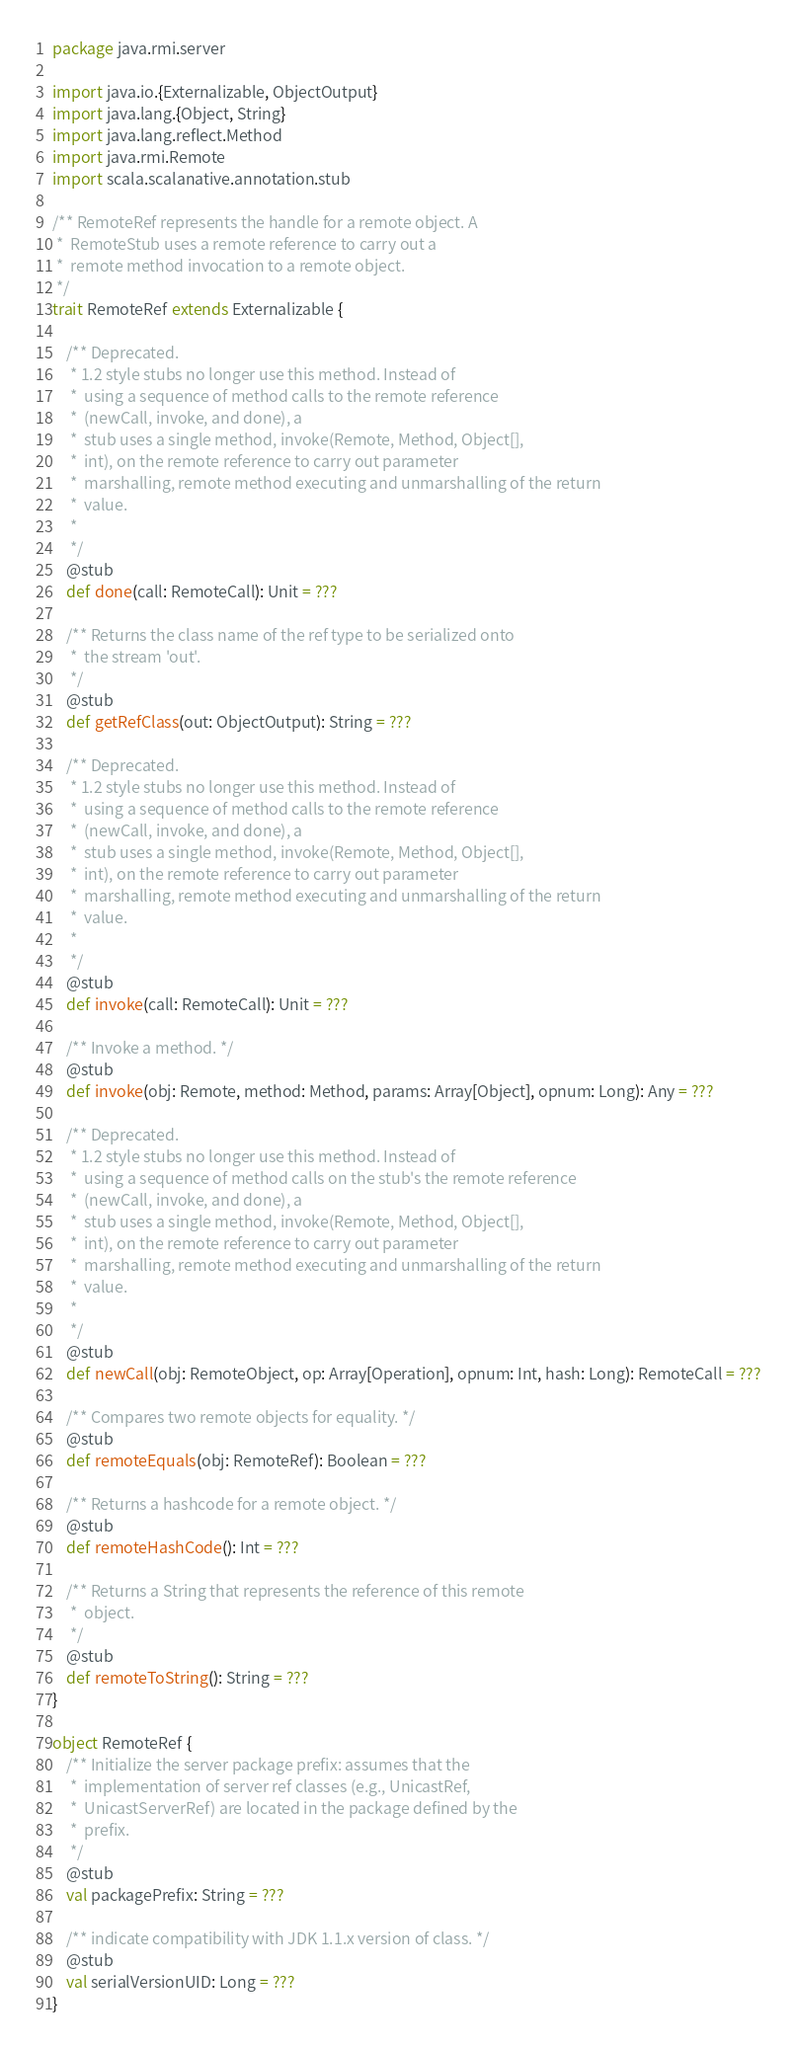Convert code to text. <code><loc_0><loc_0><loc_500><loc_500><_Scala_>package java.rmi.server

import java.io.{Externalizable, ObjectOutput}
import java.lang.{Object, String}
import java.lang.reflect.Method
import java.rmi.Remote
import scala.scalanative.annotation.stub

/** RemoteRef represents the handle for a remote object. A
 *  RemoteStub uses a remote reference to carry out a
 *  remote method invocation to a remote object.
 */
trait RemoteRef extends Externalizable {

    /** Deprecated. 
     * 1.2 style stubs no longer use this method. Instead of
     *  using a sequence of method calls to the remote reference
     *  (newCall, invoke, and done), a
     *  stub uses a single method, invoke(Remote, Method, Object[],
     *  int), on the remote reference to carry out parameter
     *  marshalling, remote method executing and unmarshalling of the return
     *  value.
     * 
     */
    @stub
    def done(call: RemoteCall): Unit = ???

    /** Returns the class name of the ref type to be serialized onto
     *  the stream 'out'.
     */
    @stub
    def getRefClass(out: ObjectOutput): String = ???

    /** Deprecated. 
     * 1.2 style stubs no longer use this method. Instead of
     *  using a sequence of method calls to the remote reference
     *  (newCall, invoke, and done), a
     *  stub uses a single method, invoke(Remote, Method, Object[],
     *  int), on the remote reference to carry out parameter
     *  marshalling, remote method executing and unmarshalling of the return
     *  value.
     * 
     */
    @stub
    def invoke(call: RemoteCall): Unit = ???

    /** Invoke a method. */
    @stub
    def invoke(obj: Remote, method: Method, params: Array[Object], opnum: Long): Any = ???

    /** Deprecated. 
     * 1.2 style stubs no longer use this method. Instead of
     *  using a sequence of method calls on the stub's the remote reference
     *  (newCall, invoke, and done), a
     *  stub uses a single method, invoke(Remote, Method, Object[],
     *  int), on the remote reference to carry out parameter
     *  marshalling, remote method executing and unmarshalling of the return
     *  value.
     * 
     */
    @stub
    def newCall(obj: RemoteObject, op: Array[Operation], opnum: Int, hash: Long): RemoteCall = ???

    /** Compares two remote objects for equality. */
    @stub
    def remoteEquals(obj: RemoteRef): Boolean = ???

    /** Returns a hashcode for a remote object. */
    @stub
    def remoteHashCode(): Int = ???

    /** Returns a String that represents the reference of this remote
     *  object.
     */
    @stub
    def remoteToString(): String = ???
}

object RemoteRef {
    /** Initialize the server package prefix: assumes that the
     *  implementation of server ref classes (e.g., UnicastRef,
     *  UnicastServerRef) are located in the package defined by the
     *  prefix.
     */
    @stub
    val packagePrefix: String = ???

    /** indicate compatibility with JDK 1.1.x version of class. */
    @stub
    val serialVersionUID: Long = ???
}
</code> 